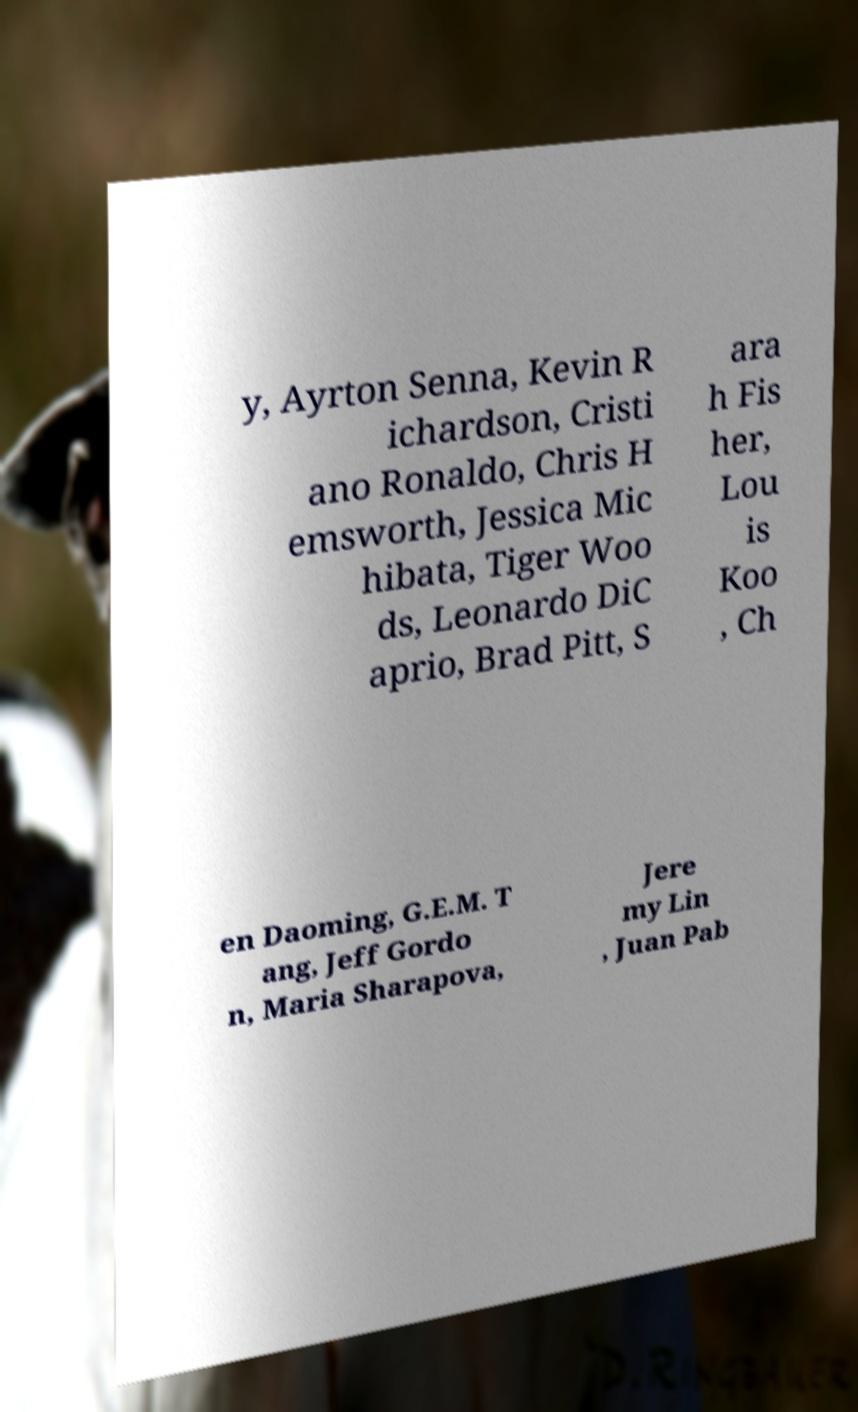What messages or text are displayed in this image? I need them in a readable, typed format. y, Ayrton Senna, Kevin R ichardson, Cristi ano Ronaldo, Chris H emsworth, Jessica Mic hibata, Tiger Woo ds, Leonardo DiC aprio, Brad Pitt, S ara h Fis her, Lou is Koo , Ch en Daoming, G.E.M. T ang, Jeff Gordo n, Maria Sharapova, Jere my Lin , Juan Pab 